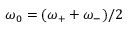<formula> <loc_0><loc_0><loc_500><loc_500>\omega _ { 0 } = ( \omega _ { + } + \omega _ { - } ) / 2</formula> 